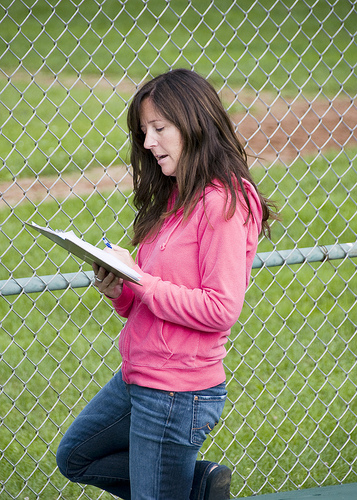<image>
Can you confirm if the girl is on the grass? Yes. Looking at the image, I can see the girl is positioned on top of the grass, with the grass providing support. 